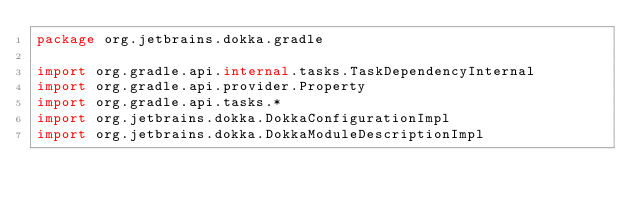<code> <loc_0><loc_0><loc_500><loc_500><_Kotlin_>package org.jetbrains.dokka.gradle

import org.gradle.api.internal.tasks.TaskDependencyInternal
import org.gradle.api.provider.Property
import org.gradle.api.tasks.*
import org.jetbrains.dokka.DokkaConfigurationImpl
import org.jetbrains.dokka.DokkaModuleDescriptionImpl</code> 